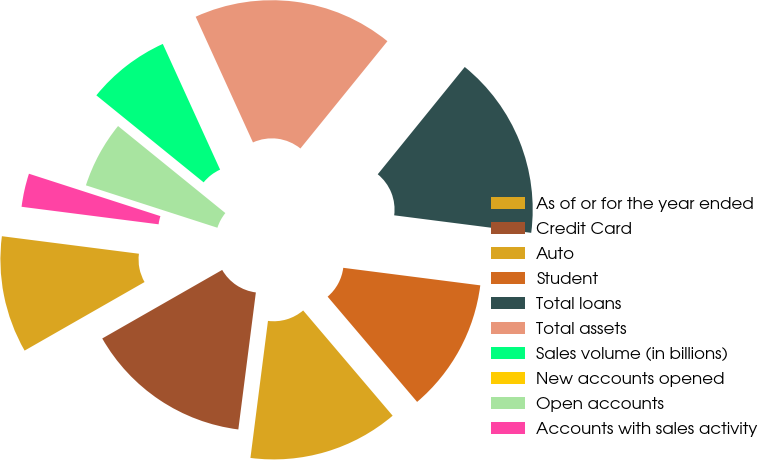<chart> <loc_0><loc_0><loc_500><loc_500><pie_chart><fcel>As of or for the year ended<fcel>Credit Card<fcel>Auto<fcel>Student<fcel>Total loans<fcel>Total assets<fcel>Sales volume (in billions)<fcel>New accounts opened<fcel>Open accounts<fcel>Accounts with sales activity<nl><fcel>10.29%<fcel>14.71%<fcel>13.24%<fcel>11.76%<fcel>16.18%<fcel>17.65%<fcel>7.35%<fcel>0.0%<fcel>5.88%<fcel>2.94%<nl></chart> 